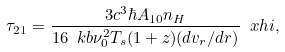<formula> <loc_0><loc_0><loc_500><loc_500>\tau _ { 2 1 } = \frac { 3 c ^ { 3 } \hbar { A } _ { 1 0 } n _ { H } } { 1 6 \ k b \nu _ { 0 } ^ { 2 } T _ { s } ( 1 + z ) ( d v _ { r } / d r ) } \ x h i ,</formula> 